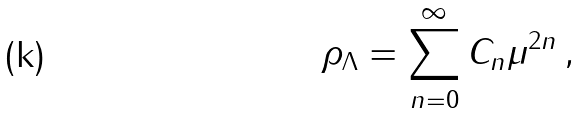<formula> <loc_0><loc_0><loc_500><loc_500>\rho _ { \Lambda } = \sum ^ { \infty } _ { n = 0 } C _ { n } \mu ^ { 2 n } \, ,</formula> 